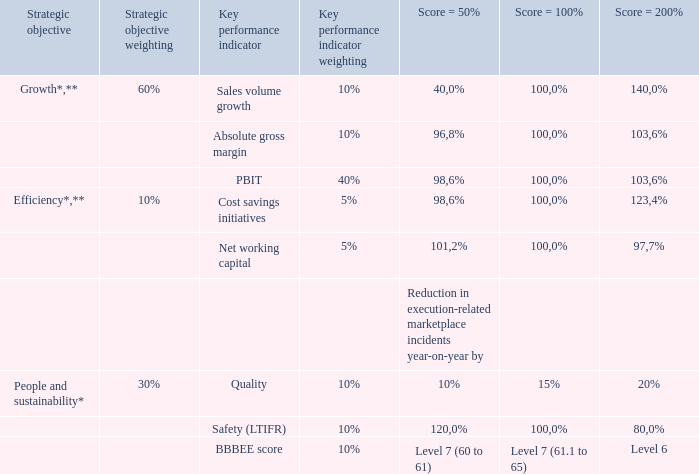Group and business unit performance factors
The underlying values and weightings for each KPI are set and approved by the remuneration committee in advance of each year to determine parameters for the STI in the form of a balanced scorecard. Below is the group STI scorecard for FY19 that applied to the CEO, CFO, executive directors, prescribed officers and other participants:
* The actual targets have not been provided as they are linked to budget and considered commercially sensitive information.
** For the key performance indicators within the growth and efficiency strategic objectives, the targeted percentages for “threshold”, “on-target” and
“stretch” as set out above per key performance indicator represent the targeted percentage achievement of the underlying budgeted amounts.
Which strategic objective has the highest weightage? Growth. Some strategy has a '*', what does this strategy relate to? Budget. How much does net working capital account for in Efficiency? 
Answer scale should be: percent. 5%/10%
Answer: 50. Which key performance indicator accounts for two thirds in Growth? 40%/60%
Answer: pbit. Why haven't the actual targets been provided? As they are linked to budget and considered commercially sensitive information. To whom did the group STI scorecard for FY19 apply? The ceo, cfo, executive directors, prescribed officers and other participants. How many key performance indicators that have the same weightage of 10%? Sales volume growth##Absolute gross margin##Quality##Safety (LTIFR)##BBBEE score
Answer: 5. 